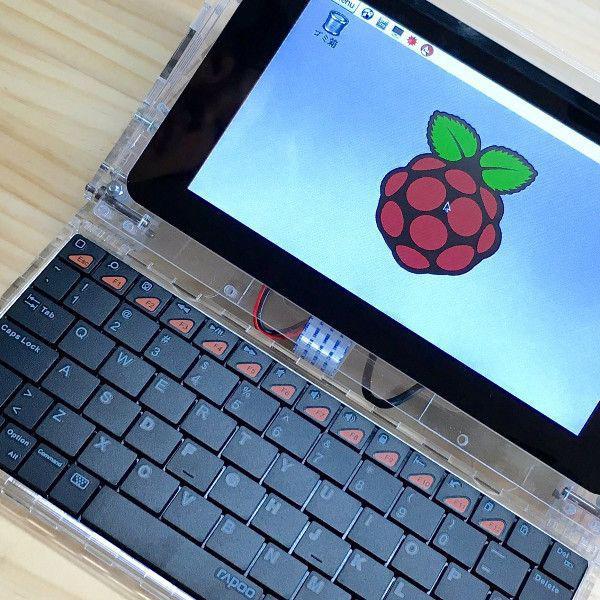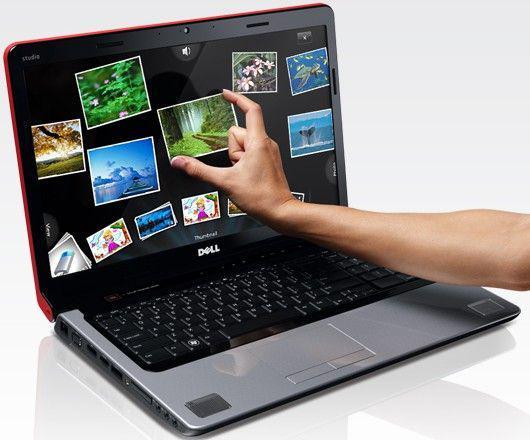The first image is the image on the left, the second image is the image on the right. Assess this claim about the two images: "A smartphone and a tablet are laying on top of a laptop keyboard.". Correct or not? Answer yes or no. No. The first image is the image on the left, the second image is the image on the right. Analyze the images presented: Is the assertion "One image includes a phone resting on a keyboard and near a device with a larger screen rimmed in white." valid? Answer yes or no. No. 